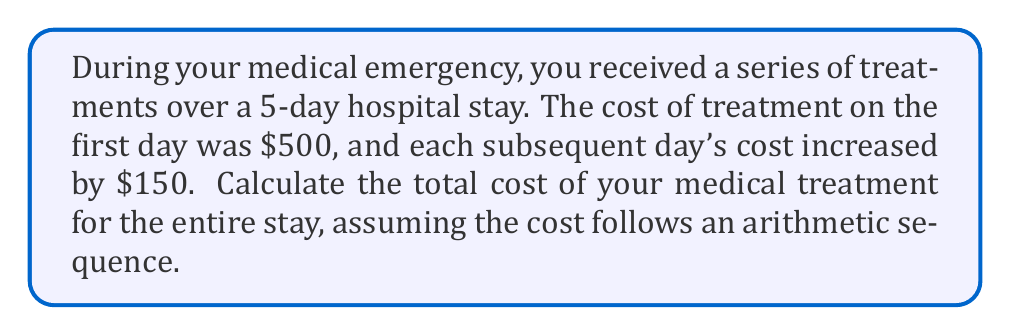Could you help me with this problem? Let's approach this step-by-step using the arithmetic sequence formula:

1) First, identify the components of the arithmetic sequence:
   - $a_1 = 500$ (first term)
   - $d = 150$ (common difference)
   - $n = 5$ (number of terms)

2) The formula for the sum of an arithmetic sequence is:

   $S_n = \frac{n}{2}(a_1 + a_n)$

   where $a_n$ is the last term.

3) To find $a_n$, use the formula:

   $a_n = a_1 + (n-1)d$
   $a_5 = 500 + (5-1)150 = 500 + 600 = 1100$

4) Now we can substitute into the sum formula:

   $S_5 = \frac{5}{2}(500 + 1100)$

5) Simplify:
   
   $S_5 = \frac{5}{2}(1600) = 5(800) = 4000$

Therefore, the total cost of your medical treatment for the 5-day stay is $4000.
Answer: $4000 